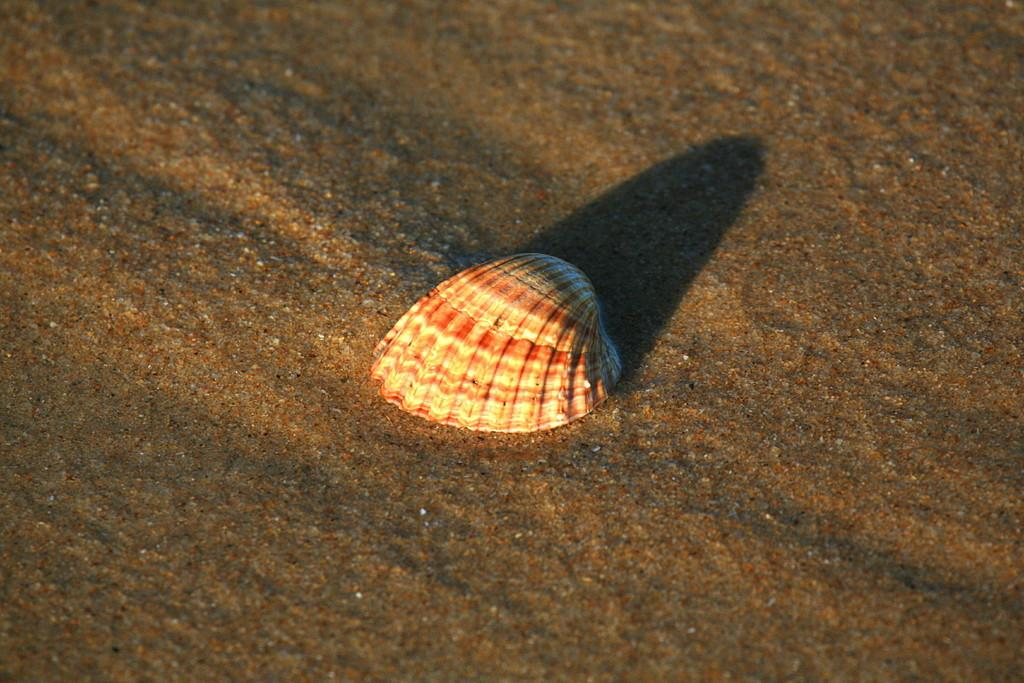What type of terrain is visible in the image? There is sand in the image. Can you describe the condition of the sand? The sand appears to be wet. What other object can be seen in the image? There is a shell in the image. What is the color of the shell? The shell is white in color. Are there any additional colors on the shell? Yes, the shell has red color shades on it. What type of trade is happening in the image? There is no trade happening in the image; it features sand and a shell. Can you describe the veins in the image? There are no veins present in the image; it features sand and a shell. 